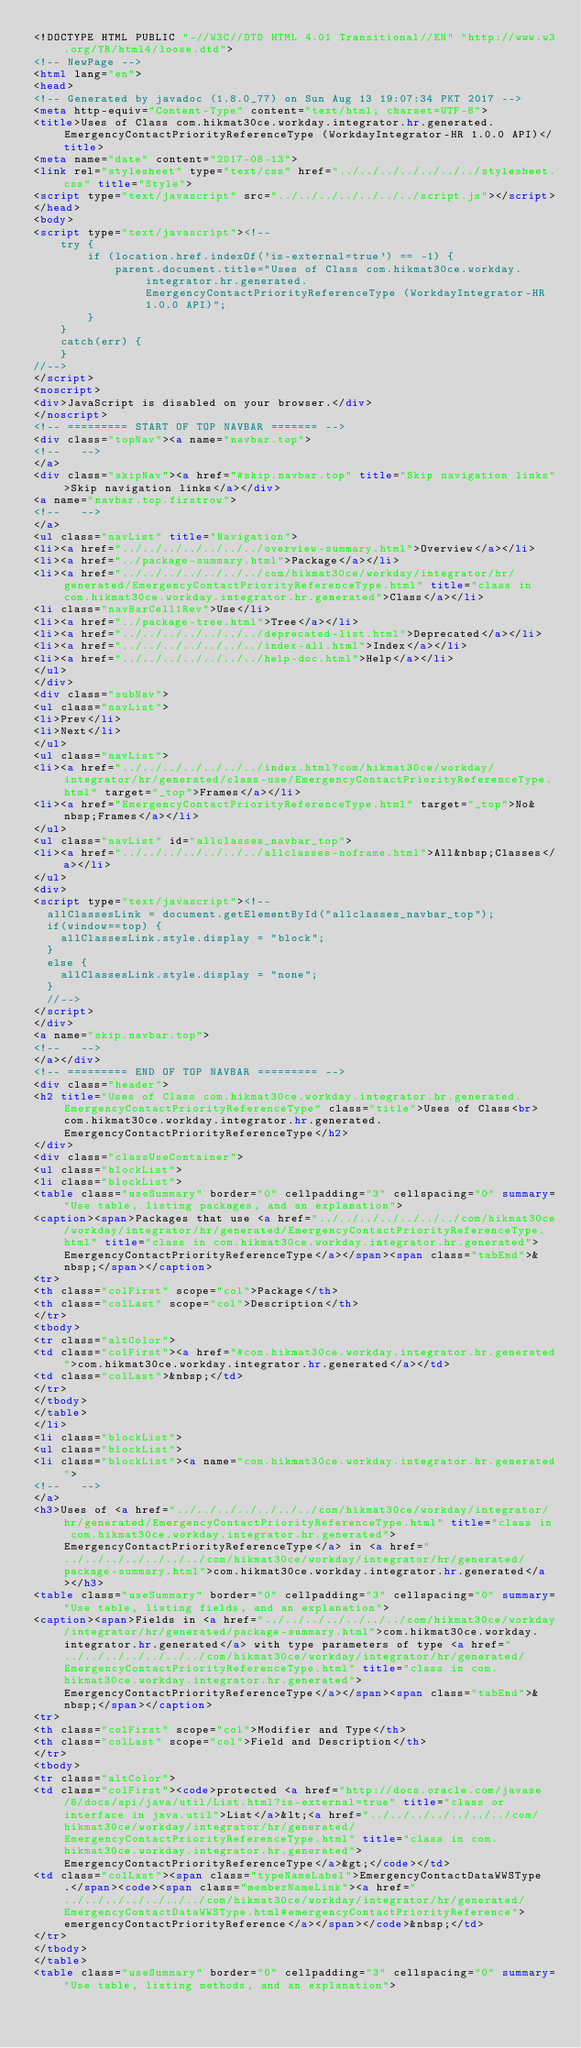Convert code to text. <code><loc_0><loc_0><loc_500><loc_500><_HTML_><!DOCTYPE HTML PUBLIC "-//W3C//DTD HTML 4.01 Transitional//EN" "http://www.w3.org/TR/html4/loose.dtd">
<!-- NewPage -->
<html lang="en">
<head>
<!-- Generated by javadoc (1.8.0_77) on Sun Aug 13 19:07:34 PKT 2017 -->
<meta http-equiv="Content-Type" content="text/html; charset=UTF-8">
<title>Uses of Class com.hikmat30ce.workday.integrator.hr.generated.EmergencyContactPriorityReferenceType (WorkdayIntegrator-HR 1.0.0 API)</title>
<meta name="date" content="2017-08-13">
<link rel="stylesheet" type="text/css" href="../../../../../../../stylesheet.css" title="Style">
<script type="text/javascript" src="../../../../../../../script.js"></script>
</head>
<body>
<script type="text/javascript"><!--
    try {
        if (location.href.indexOf('is-external=true') == -1) {
            parent.document.title="Uses of Class com.hikmat30ce.workday.integrator.hr.generated.EmergencyContactPriorityReferenceType (WorkdayIntegrator-HR 1.0.0 API)";
        }
    }
    catch(err) {
    }
//-->
</script>
<noscript>
<div>JavaScript is disabled on your browser.</div>
</noscript>
<!-- ========= START OF TOP NAVBAR ======= -->
<div class="topNav"><a name="navbar.top">
<!--   -->
</a>
<div class="skipNav"><a href="#skip.navbar.top" title="Skip navigation links">Skip navigation links</a></div>
<a name="navbar.top.firstrow">
<!--   -->
</a>
<ul class="navList" title="Navigation">
<li><a href="../../../../../../../overview-summary.html">Overview</a></li>
<li><a href="../package-summary.html">Package</a></li>
<li><a href="../../../../../../../com/hikmat30ce/workday/integrator/hr/generated/EmergencyContactPriorityReferenceType.html" title="class in com.hikmat30ce.workday.integrator.hr.generated">Class</a></li>
<li class="navBarCell1Rev">Use</li>
<li><a href="../package-tree.html">Tree</a></li>
<li><a href="../../../../../../../deprecated-list.html">Deprecated</a></li>
<li><a href="../../../../../../../index-all.html">Index</a></li>
<li><a href="../../../../../../../help-doc.html">Help</a></li>
</ul>
</div>
<div class="subNav">
<ul class="navList">
<li>Prev</li>
<li>Next</li>
</ul>
<ul class="navList">
<li><a href="../../../../../../../index.html?com/hikmat30ce/workday/integrator/hr/generated/class-use/EmergencyContactPriorityReferenceType.html" target="_top">Frames</a></li>
<li><a href="EmergencyContactPriorityReferenceType.html" target="_top">No&nbsp;Frames</a></li>
</ul>
<ul class="navList" id="allclasses_navbar_top">
<li><a href="../../../../../../../allclasses-noframe.html">All&nbsp;Classes</a></li>
</ul>
<div>
<script type="text/javascript"><!--
  allClassesLink = document.getElementById("allclasses_navbar_top");
  if(window==top) {
    allClassesLink.style.display = "block";
  }
  else {
    allClassesLink.style.display = "none";
  }
  //-->
</script>
</div>
<a name="skip.navbar.top">
<!--   -->
</a></div>
<!-- ========= END OF TOP NAVBAR ========= -->
<div class="header">
<h2 title="Uses of Class com.hikmat30ce.workday.integrator.hr.generated.EmergencyContactPriorityReferenceType" class="title">Uses of Class<br>com.hikmat30ce.workday.integrator.hr.generated.EmergencyContactPriorityReferenceType</h2>
</div>
<div class="classUseContainer">
<ul class="blockList">
<li class="blockList">
<table class="useSummary" border="0" cellpadding="3" cellspacing="0" summary="Use table, listing packages, and an explanation">
<caption><span>Packages that use <a href="../../../../../../../com/hikmat30ce/workday/integrator/hr/generated/EmergencyContactPriorityReferenceType.html" title="class in com.hikmat30ce.workday.integrator.hr.generated">EmergencyContactPriorityReferenceType</a></span><span class="tabEnd">&nbsp;</span></caption>
<tr>
<th class="colFirst" scope="col">Package</th>
<th class="colLast" scope="col">Description</th>
</tr>
<tbody>
<tr class="altColor">
<td class="colFirst"><a href="#com.hikmat30ce.workday.integrator.hr.generated">com.hikmat30ce.workday.integrator.hr.generated</a></td>
<td class="colLast">&nbsp;</td>
</tr>
</tbody>
</table>
</li>
<li class="blockList">
<ul class="blockList">
<li class="blockList"><a name="com.hikmat30ce.workday.integrator.hr.generated">
<!--   -->
</a>
<h3>Uses of <a href="../../../../../../../com/hikmat30ce/workday/integrator/hr/generated/EmergencyContactPriorityReferenceType.html" title="class in com.hikmat30ce.workday.integrator.hr.generated">EmergencyContactPriorityReferenceType</a> in <a href="../../../../../../../com/hikmat30ce/workday/integrator/hr/generated/package-summary.html">com.hikmat30ce.workday.integrator.hr.generated</a></h3>
<table class="useSummary" border="0" cellpadding="3" cellspacing="0" summary="Use table, listing fields, and an explanation">
<caption><span>Fields in <a href="../../../../../../../com/hikmat30ce/workday/integrator/hr/generated/package-summary.html">com.hikmat30ce.workday.integrator.hr.generated</a> with type parameters of type <a href="../../../../../../../com/hikmat30ce/workday/integrator/hr/generated/EmergencyContactPriorityReferenceType.html" title="class in com.hikmat30ce.workday.integrator.hr.generated">EmergencyContactPriorityReferenceType</a></span><span class="tabEnd">&nbsp;</span></caption>
<tr>
<th class="colFirst" scope="col">Modifier and Type</th>
<th class="colLast" scope="col">Field and Description</th>
</tr>
<tbody>
<tr class="altColor">
<td class="colFirst"><code>protected <a href="http://docs.oracle.com/javase/8/docs/api/java/util/List.html?is-external=true" title="class or interface in java.util">List</a>&lt;<a href="../../../../../../../com/hikmat30ce/workday/integrator/hr/generated/EmergencyContactPriorityReferenceType.html" title="class in com.hikmat30ce.workday.integrator.hr.generated">EmergencyContactPriorityReferenceType</a>&gt;</code></td>
<td class="colLast"><span class="typeNameLabel">EmergencyContactDataWWSType.</span><code><span class="memberNameLink"><a href="../../../../../../../com/hikmat30ce/workday/integrator/hr/generated/EmergencyContactDataWWSType.html#emergencyContactPriorityReference">emergencyContactPriorityReference</a></span></code>&nbsp;</td>
</tr>
</tbody>
</table>
<table class="useSummary" border="0" cellpadding="3" cellspacing="0" summary="Use table, listing methods, and an explanation"></code> 